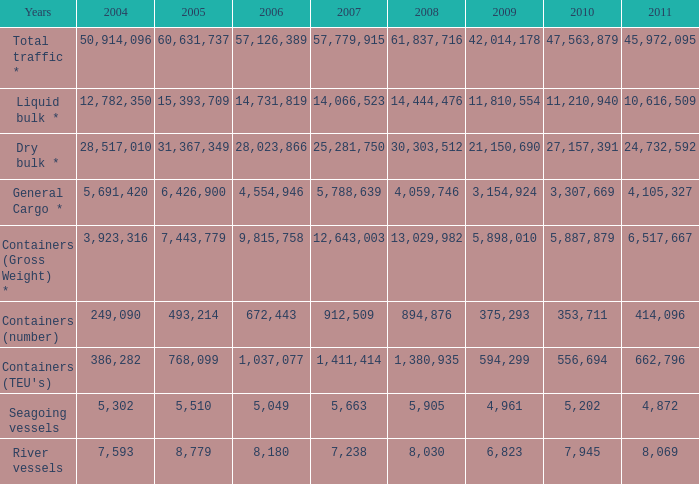What was the average value in 2005 when 2008 is 61,837,716, and a 2006 is more than 57,126,389? None. 